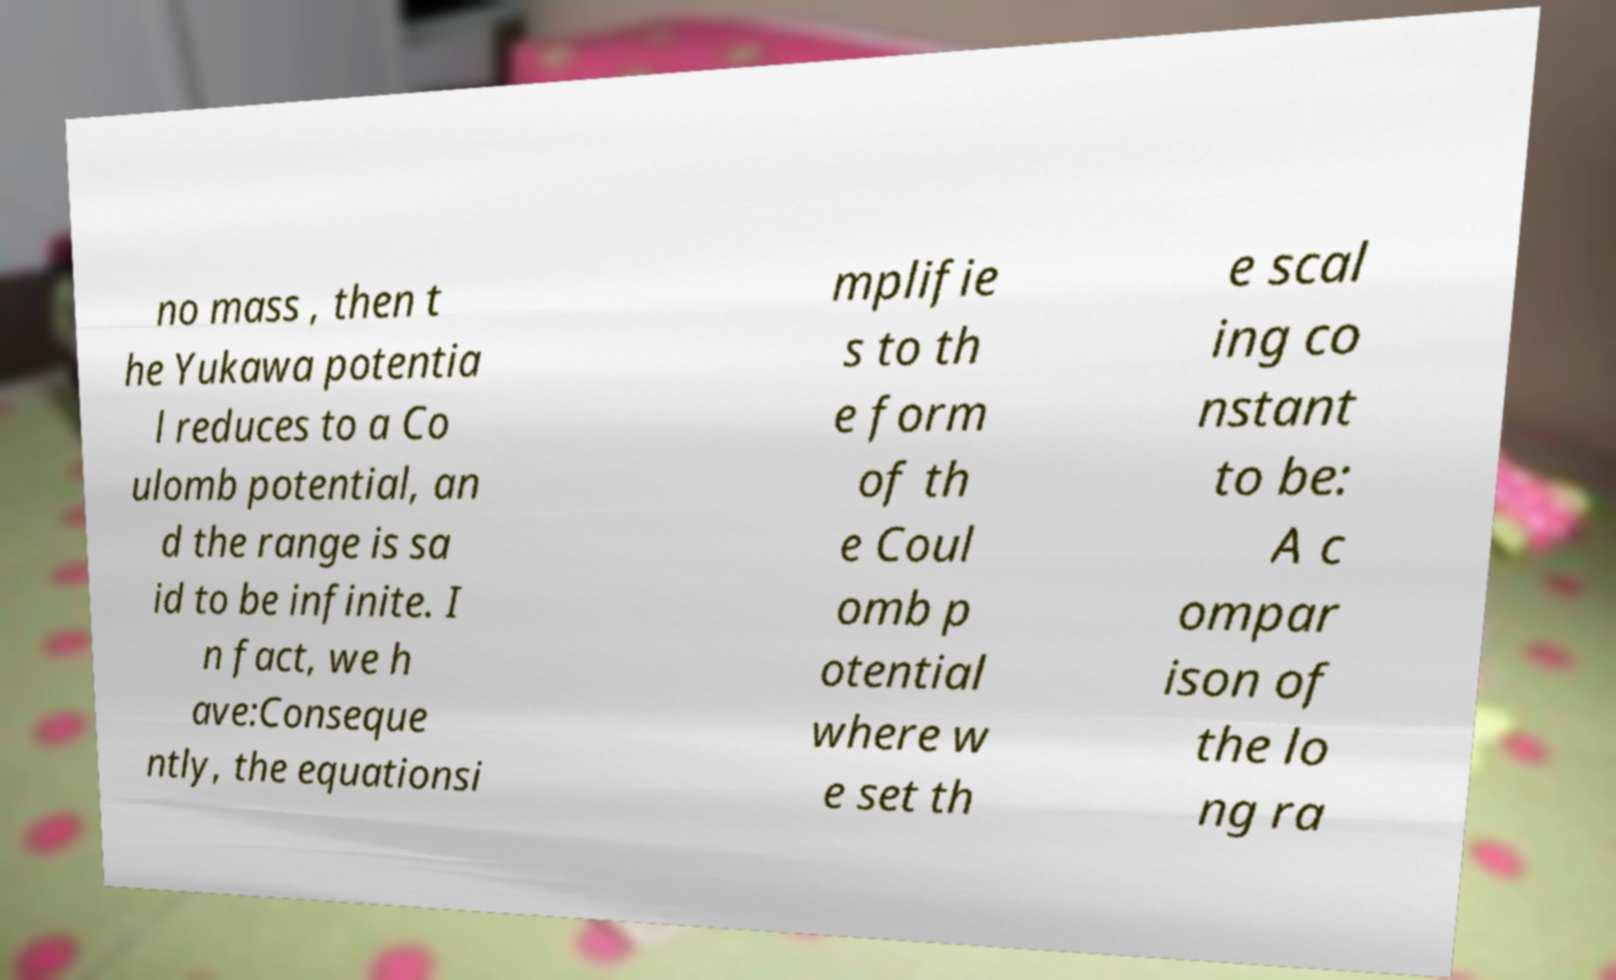I need the written content from this picture converted into text. Can you do that? no mass , then t he Yukawa potentia l reduces to a Co ulomb potential, an d the range is sa id to be infinite. I n fact, we h ave:Conseque ntly, the equationsi mplifie s to th e form of th e Coul omb p otential where w e set th e scal ing co nstant to be: A c ompar ison of the lo ng ra 